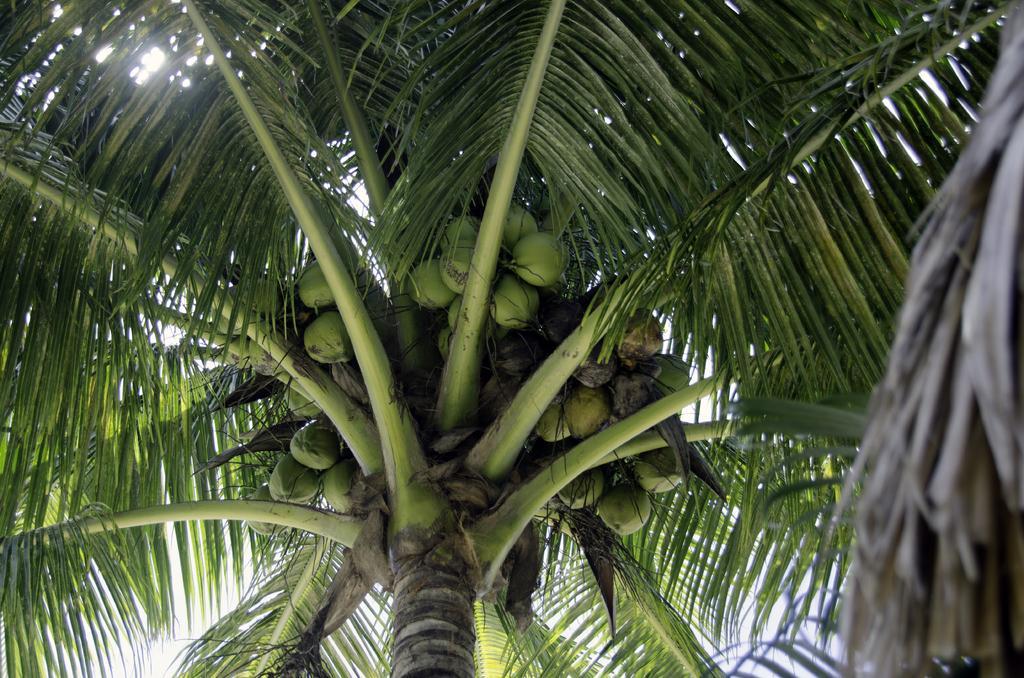Describe this image in one or two sentences. These are the coconuts and this is the coconut tree. 